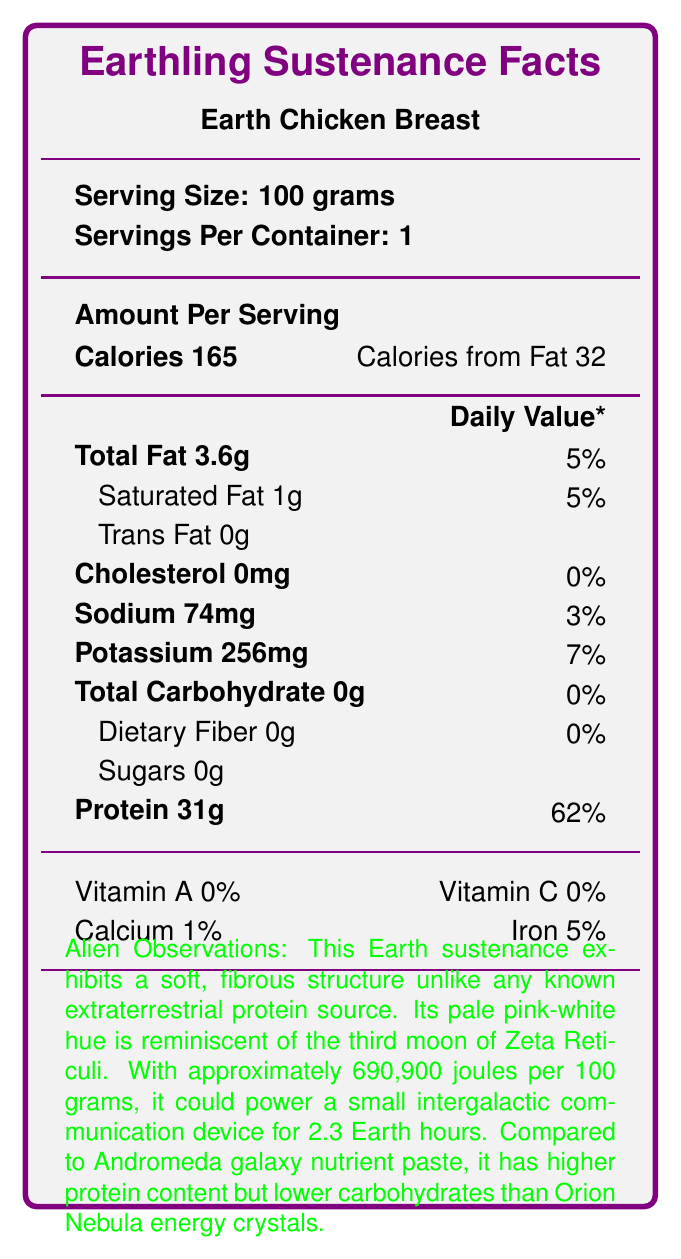what is the serving size for Earth Chicken Breast? The serving size is clearly indicated at the top of the document as "Serving Size: 100 grams".
Answer: 100 grams how many calories are in one serving of Earth Chicken Breast? The document lists "Calories 165" under the "Amount Per Serving" section.
Answer: 165 what is the percentage of daily value for protein in Earth Chicken Breast? The document notes "Protein 31g" and gives "\% Daily Value" as 62%.
Answer: 62% how much total fat is in one serving of Earth Chicken Breast? In the "Amount Per Serving" section, "Total Fat 3.6g" is specified.
Answer: 3.6 grams what is the sodium content in milligrams? Under the listed nutrients, sodium is shown as "Sodium 74mg".
Answer: 74 milligrams which vitamin has the highest daily value percentage in Earth Chicken Breast? A. Vitamin A B. Vitamin C C. Calcium D. Iron The document lists Iron as having 5\% of the daily value, while Vitamin A and Vitamin C are both 0\% and Calcium is 1\%.
Answer: D. Iron how does the protein content in Earth Chicken Breast compare to Andromeda galaxy nutrient paste? According to the "Alien Observations" section, the Earth sustenance has "higher protein content" compared to Andromeda galaxy nutrient paste.
Answer: Higher is there any trans fat in Earth Chicken Breast? The document clearly states "Trans Fat 0g".
Answer: No summarize the main idea of the document. The document includes standard nutritional facts for Earth Chicken Breast such as serving size, calories, macronutrient amounts, and vitamins. It also includes unique observations from an extraterrestrial viewpoint, offering comparisons to alien foods and noting specific characteristics of the chicken breast.
Answer: The document provides nutritional information about Earth Chicken Breast, detailing its macronutrient content like protein, fat, and carbohydrates, along with vitamins and minerals. It also includes observations from an extraterrestrial perspective, comparing it to known alien food sources. what is the total carbohydrate content in Earth Chicken Breast? In the "Total Carbohydrate" section, it is indicated as "Total Carbohydrate 0g".
Answer: 0 grams what is the percentage of daily value for sodium? The document shows this information under the sodium section as "Sodium 74mg" and indicates it is 3\% of the daily value.
Answer: 3% how much potassium does Earth Chicken Breast contain per serving? Listed in the document under the minerals section, potassium is noted as "Potassium 256mg".
Answer: 256 milligrams if you consumed two servings of Earth Chicken Breast, how much protein would you intake? Each serving contains 31 grams of protein, so two servings would be 31 grams x 2 = 62 grams.
Answer: 62 grams does Earth Chicken Breast contain dietary fiber? Listed under carbohydrates, dietary fiber is shown as "Dietary Fiber 0g".
Answer: No how much energy content does Earth Chicken Breast provide per 100 grams in joules? The "Alien Observations" section states that the energy content is approximately 690,900 joules per 100 grams.
Answer: 690,900 joules how many Earth hours can the energy from one serving of Earth Chicken Breast power a small intergalactic communication device? According to the "Alien Observations" section, it states "sufficient to power a small intergalactic communication device for 2.3 Earth hours".
Answer: 2.3 hours is Earth Chicken Breast derived from a creature capable of space travel? The "Earth-Specific Notes" section mentions that the chicken is a creature "despite its inability to traverse interstellar distances".
Answer: No what is the cholesterol level in Earth Chicken Breast? Cholesterol is not listed among the nutrients in the document.
Answer: Cannot be determined 